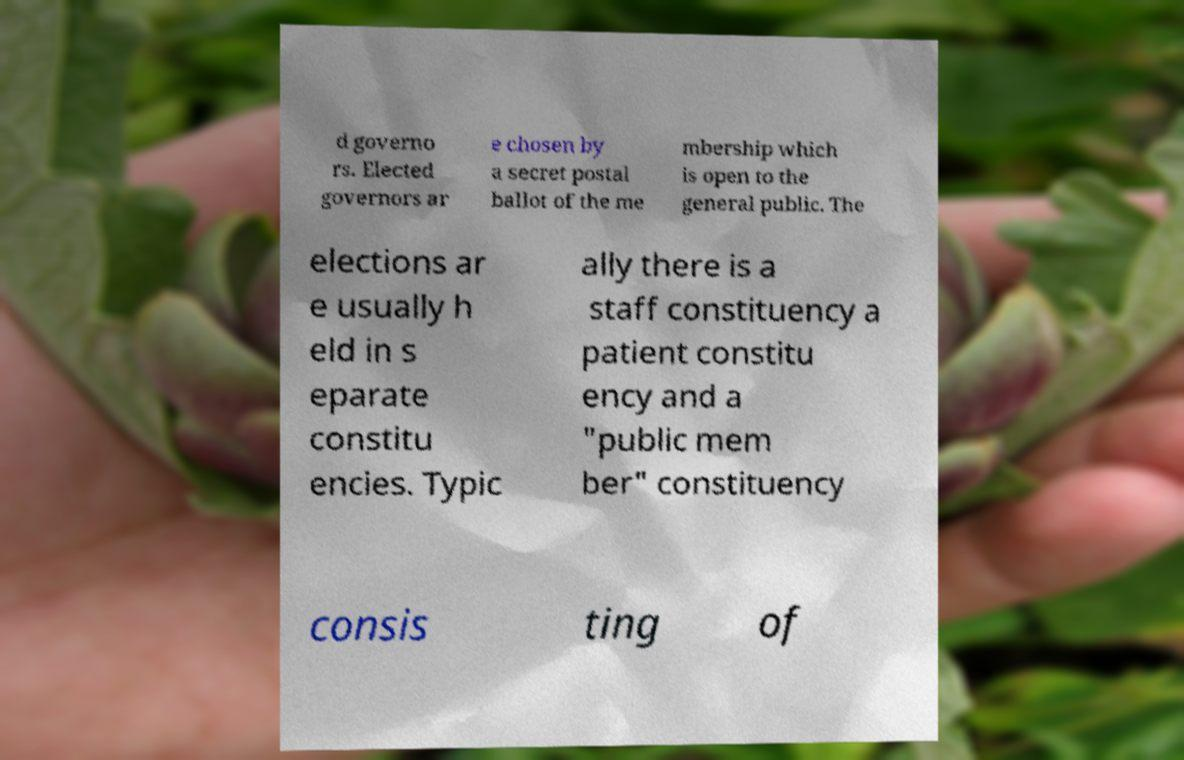For documentation purposes, I need the text within this image transcribed. Could you provide that? d governo rs. Elected governors ar e chosen by a secret postal ballot of the me mbership which is open to the general public. The elections ar e usually h eld in s eparate constitu encies. Typic ally there is a staff constituency a patient constitu ency and a "public mem ber" constituency consis ting of 